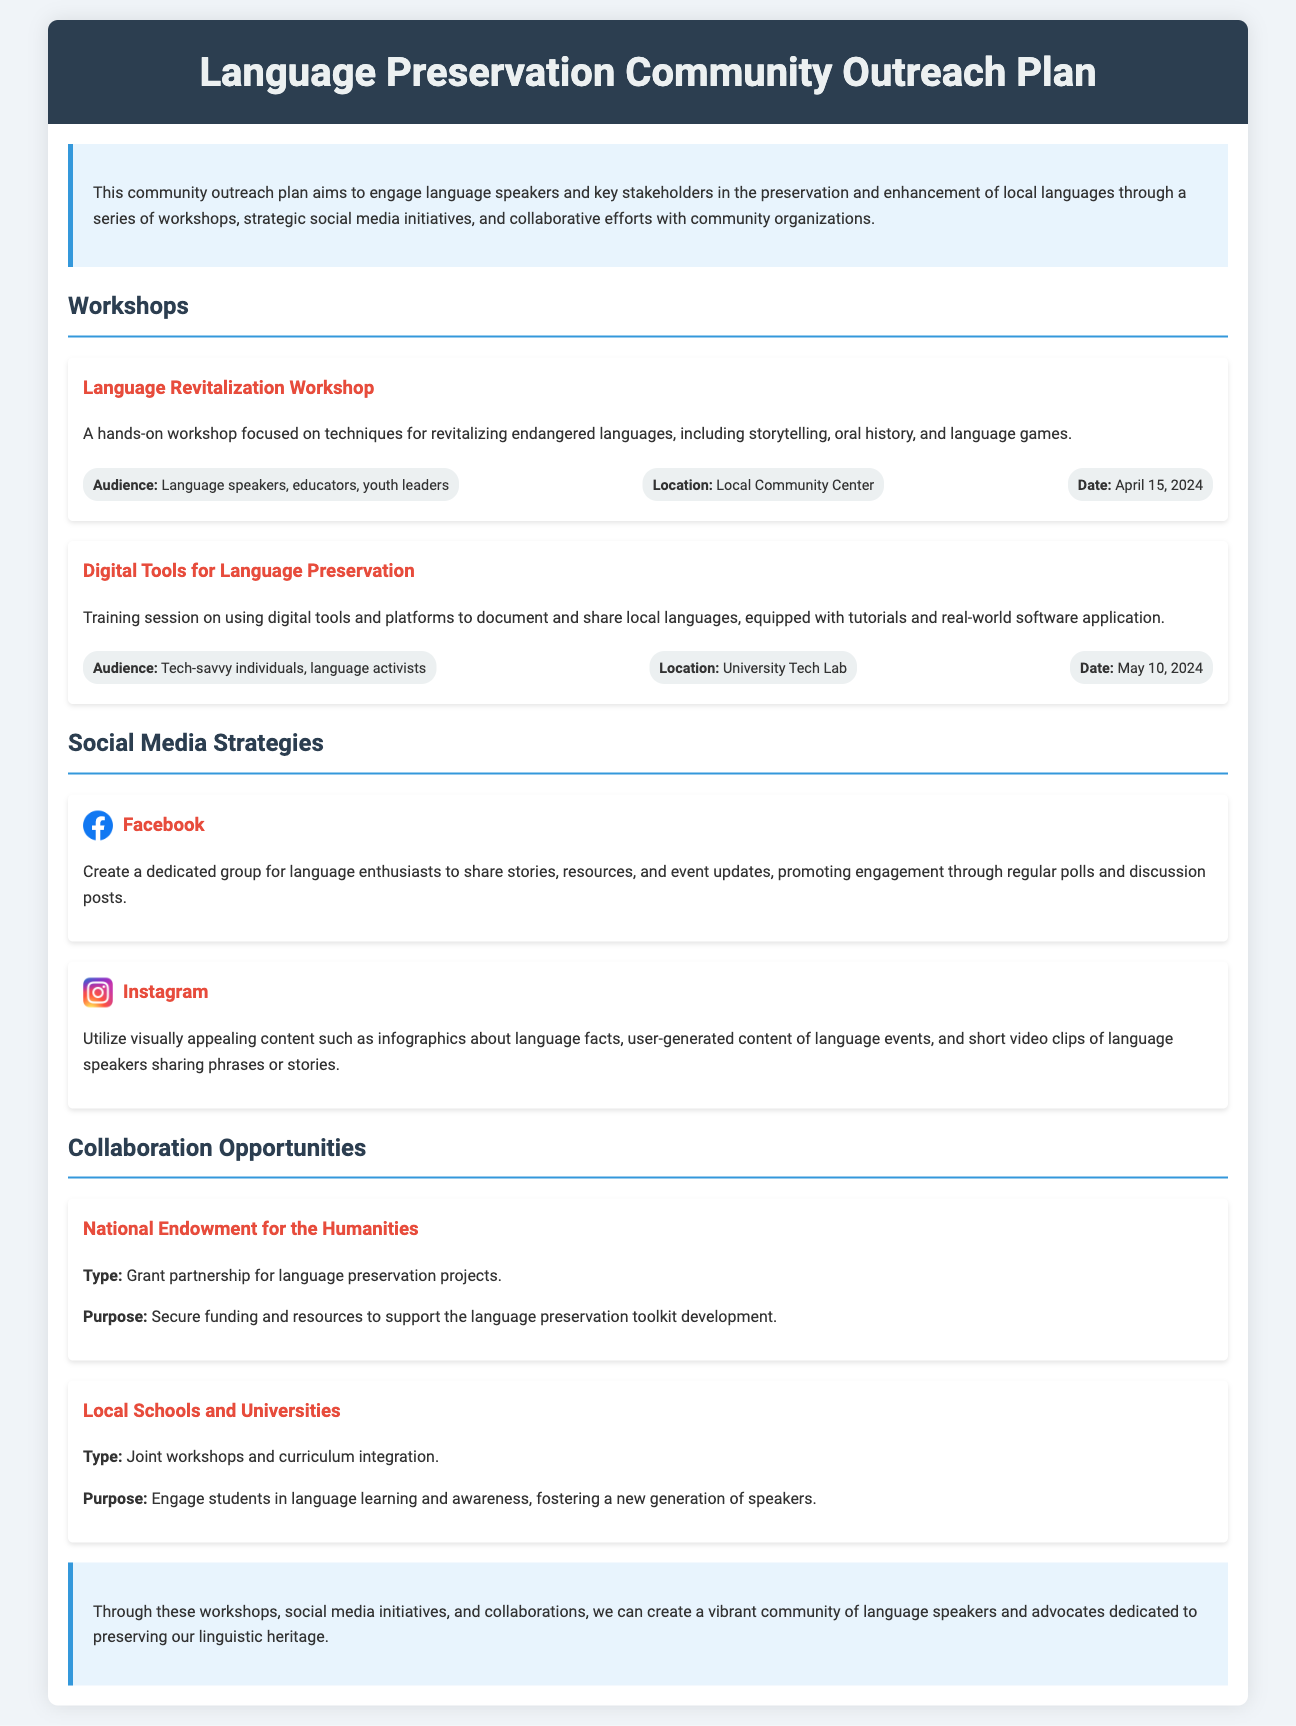What is the title of the outreach plan? The title is found at the top of the document.
Answer: Language Preservation Community Outreach Plan When is the Language Revitalization Workshop scheduled? The date can be found in the workshops section of the document.
Answer: April 15, 2024 What organization is mentioned for grant partnership? The organization's name is detailed under the collaboration opportunities section.
Answer: National Endowment for the Humanities What is the location for the Digital Tools for Language Preservation workshop? This information is provided in the workshop details section.
Answer: University Tech Lab How many social media strategies are listed in the document? The social media strategies section lists each strategy separately.
Answer: 2 What type of audience is targeted for the Language Revitalization Workshop? The target audience is specified under the workshop details.
Answer: Language speakers, educators, youth leaders What social platform is used for sharing language stories and resources? The social media section mentions a specific platform for this purpose.
Answer: Facebook What is the main purpose of collaborating with local schools and universities? The purpose is provided directly in the description under collaboration opportunities.
Answer: Engage students in language learning and awareness 